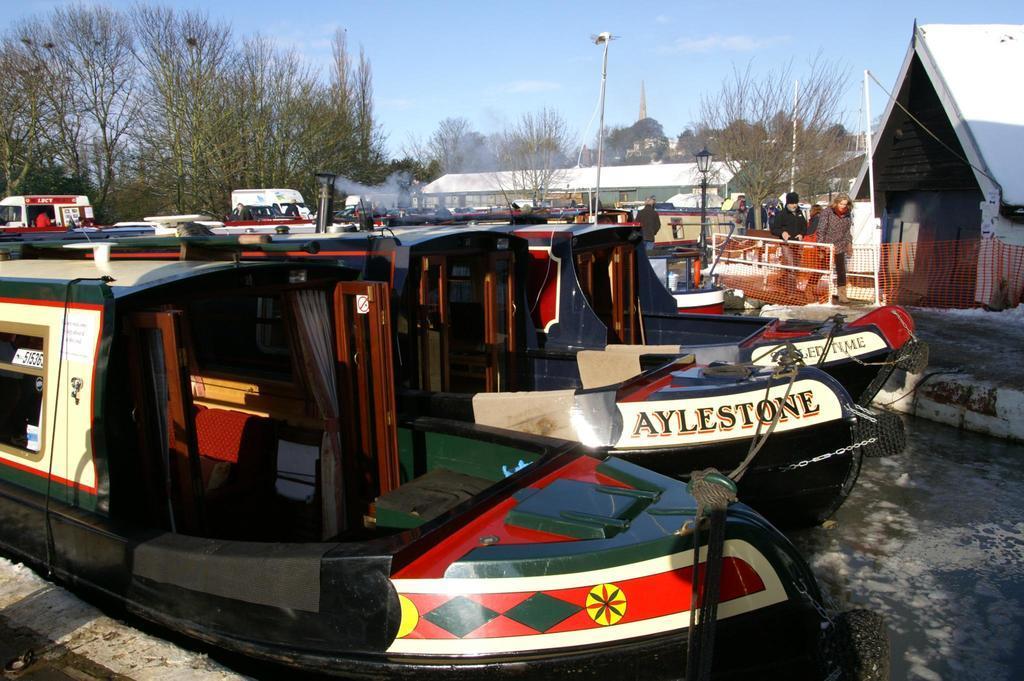How would you summarize this image in a sentence or two? In this picture we can see water at the bottom, there are some boats here, in the background there are some leaves, there is the sky at the top of the picture, we can see some people on the right side. 